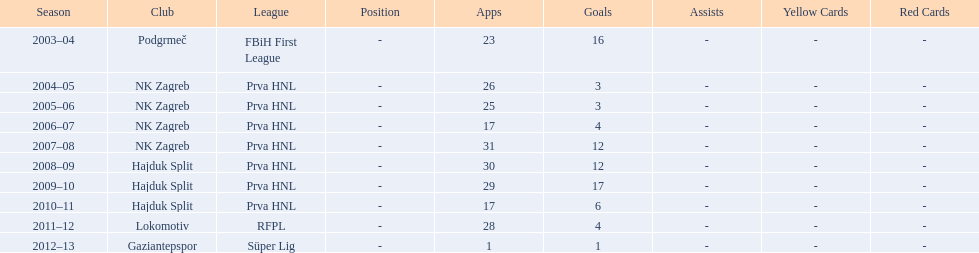The team with the most goals Hajduk Split. 